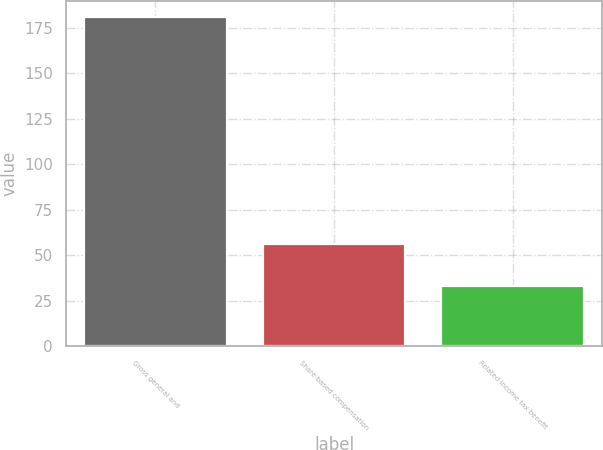Convert chart. <chart><loc_0><loc_0><loc_500><loc_500><bar_chart><fcel>Gross general and<fcel>Share-based compensation<fcel>Related income tax benefit<nl><fcel>181<fcel>56<fcel>33<nl></chart> 